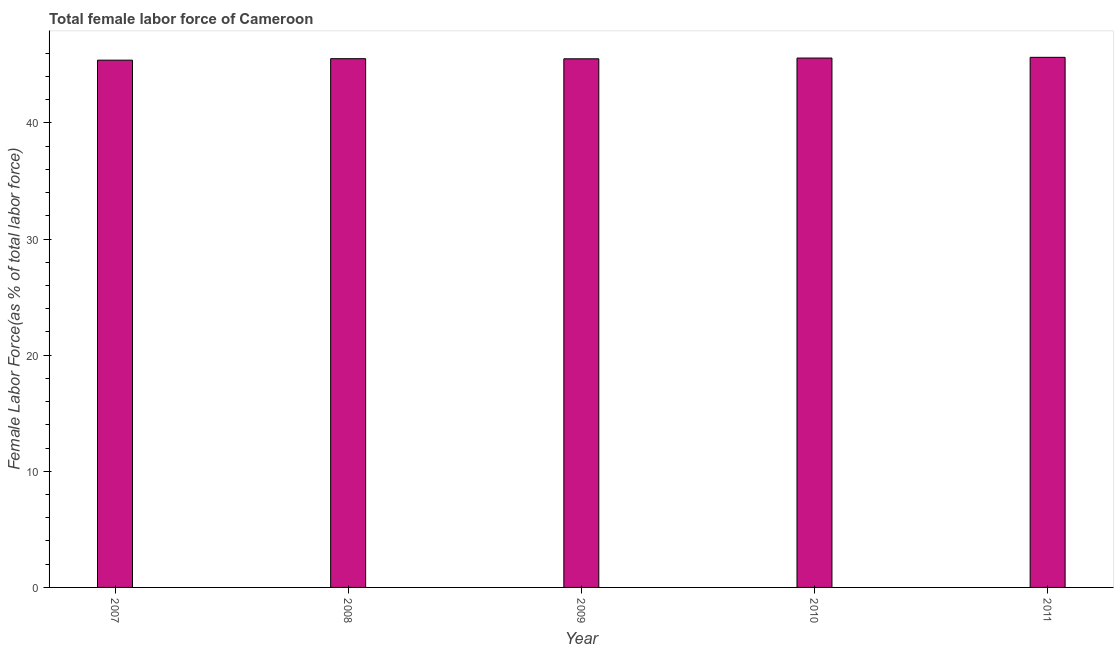Does the graph contain any zero values?
Offer a very short reply. No. Does the graph contain grids?
Provide a short and direct response. No. What is the title of the graph?
Make the answer very short. Total female labor force of Cameroon. What is the label or title of the X-axis?
Offer a very short reply. Year. What is the label or title of the Y-axis?
Offer a terse response. Female Labor Force(as % of total labor force). What is the total female labor force in 2007?
Give a very brief answer. 45.4. Across all years, what is the maximum total female labor force?
Give a very brief answer. 45.65. Across all years, what is the minimum total female labor force?
Your response must be concise. 45.4. In which year was the total female labor force maximum?
Your answer should be compact. 2011. In which year was the total female labor force minimum?
Provide a short and direct response. 2007. What is the sum of the total female labor force?
Offer a very short reply. 227.69. What is the difference between the total female labor force in 2008 and 2010?
Provide a succinct answer. -0.05. What is the average total female labor force per year?
Make the answer very short. 45.54. What is the median total female labor force?
Give a very brief answer. 45.53. Do a majority of the years between 2008 and 2010 (inclusive) have total female labor force greater than 18 %?
Offer a very short reply. Yes. Is the total female labor force in 2008 less than that in 2010?
Offer a terse response. Yes. What is the difference between the highest and the second highest total female labor force?
Ensure brevity in your answer.  0.06. What is the difference between the highest and the lowest total female labor force?
Keep it short and to the point. 0.24. In how many years, is the total female labor force greater than the average total female labor force taken over all years?
Your answer should be compact. 2. What is the difference between two consecutive major ticks on the Y-axis?
Make the answer very short. 10. What is the Female Labor Force(as % of total labor force) in 2007?
Offer a terse response. 45.4. What is the Female Labor Force(as % of total labor force) of 2008?
Offer a very short reply. 45.53. What is the Female Labor Force(as % of total labor force) in 2009?
Offer a very short reply. 45.52. What is the Female Labor Force(as % of total labor force) in 2010?
Provide a succinct answer. 45.59. What is the Female Labor Force(as % of total labor force) in 2011?
Your answer should be compact. 45.65. What is the difference between the Female Labor Force(as % of total labor force) in 2007 and 2008?
Your response must be concise. -0.13. What is the difference between the Female Labor Force(as % of total labor force) in 2007 and 2009?
Offer a terse response. -0.12. What is the difference between the Female Labor Force(as % of total labor force) in 2007 and 2010?
Your answer should be compact. -0.18. What is the difference between the Female Labor Force(as % of total labor force) in 2007 and 2011?
Give a very brief answer. -0.24. What is the difference between the Female Labor Force(as % of total labor force) in 2008 and 2009?
Make the answer very short. 0.01. What is the difference between the Female Labor Force(as % of total labor force) in 2008 and 2010?
Keep it short and to the point. -0.05. What is the difference between the Female Labor Force(as % of total labor force) in 2008 and 2011?
Ensure brevity in your answer.  -0.12. What is the difference between the Female Labor Force(as % of total labor force) in 2009 and 2010?
Your answer should be compact. -0.06. What is the difference between the Female Labor Force(as % of total labor force) in 2009 and 2011?
Your answer should be very brief. -0.13. What is the difference between the Female Labor Force(as % of total labor force) in 2010 and 2011?
Your answer should be very brief. -0.06. What is the ratio of the Female Labor Force(as % of total labor force) in 2007 to that in 2010?
Your answer should be compact. 1. What is the ratio of the Female Labor Force(as % of total labor force) in 2007 to that in 2011?
Your answer should be very brief. 0.99. What is the ratio of the Female Labor Force(as % of total labor force) in 2008 to that in 2009?
Make the answer very short. 1. What is the ratio of the Female Labor Force(as % of total labor force) in 2008 to that in 2010?
Your answer should be compact. 1. What is the ratio of the Female Labor Force(as % of total labor force) in 2009 to that in 2011?
Provide a short and direct response. 1. What is the ratio of the Female Labor Force(as % of total labor force) in 2010 to that in 2011?
Make the answer very short. 1. 